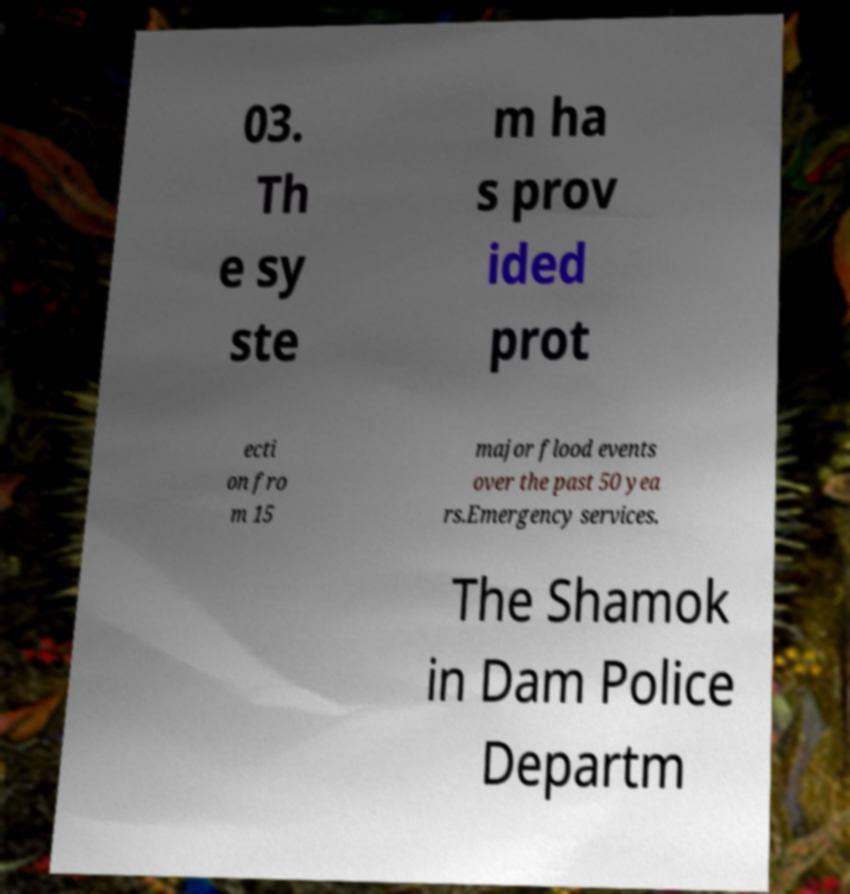Please identify and transcribe the text found in this image. 03. Th e sy ste m ha s prov ided prot ecti on fro m 15 major flood events over the past 50 yea rs.Emergency services. The Shamok in Dam Police Departm 